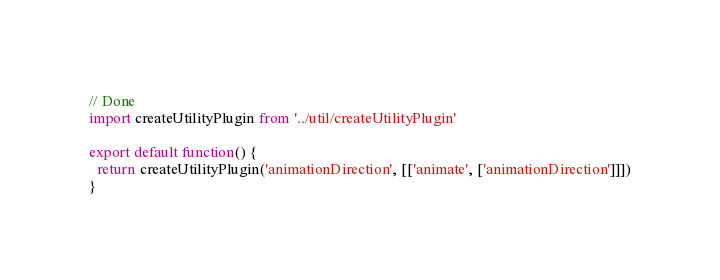<code> <loc_0><loc_0><loc_500><loc_500><_JavaScript_>// Done
import createUtilityPlugin from '../util/createUtilityPlugin'

export default function() {
  return createUtilityPlugin('animationDirection', [['animate', ['animationDirection']]])
}
</code> 